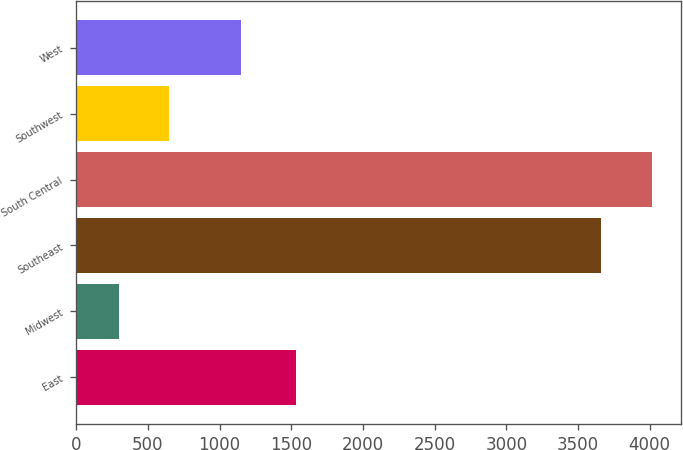Convert chart. <chart><loc_0><loc_0><loc_500><loc_500><bar_chart><fcel>East<fcel>Midwest<fcel>Southeast<fcel>South Central<fcel>Southwest<fcel>West<nl><fcel>1536<fcel>296<fcel>3663<fcel>4016.7<fcel>649.7<fcel>1151<nl></chart> 